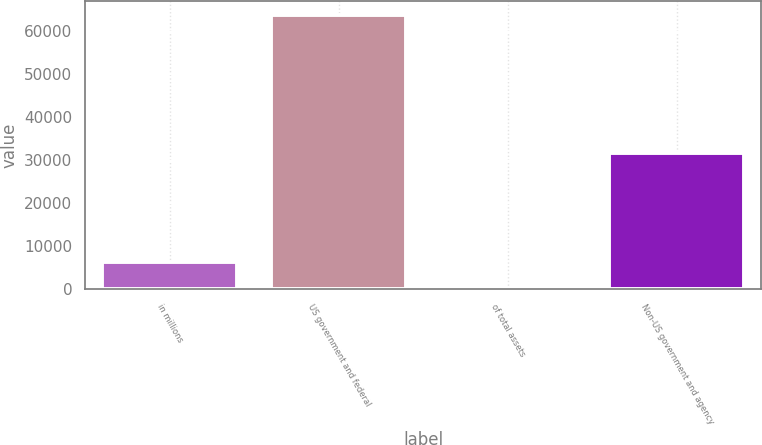Convert chart to OTSL. <chart><loc_0><loc_0><loc_500><loc_500><bar_chart><fcel>in millions<fcel>US government and federal<fcel>of total assets<fcel>Non-US government and agency<nl><fcel>6391.06<fcel>63844<fcel>7.4<fcel>31772<nl></chart> 